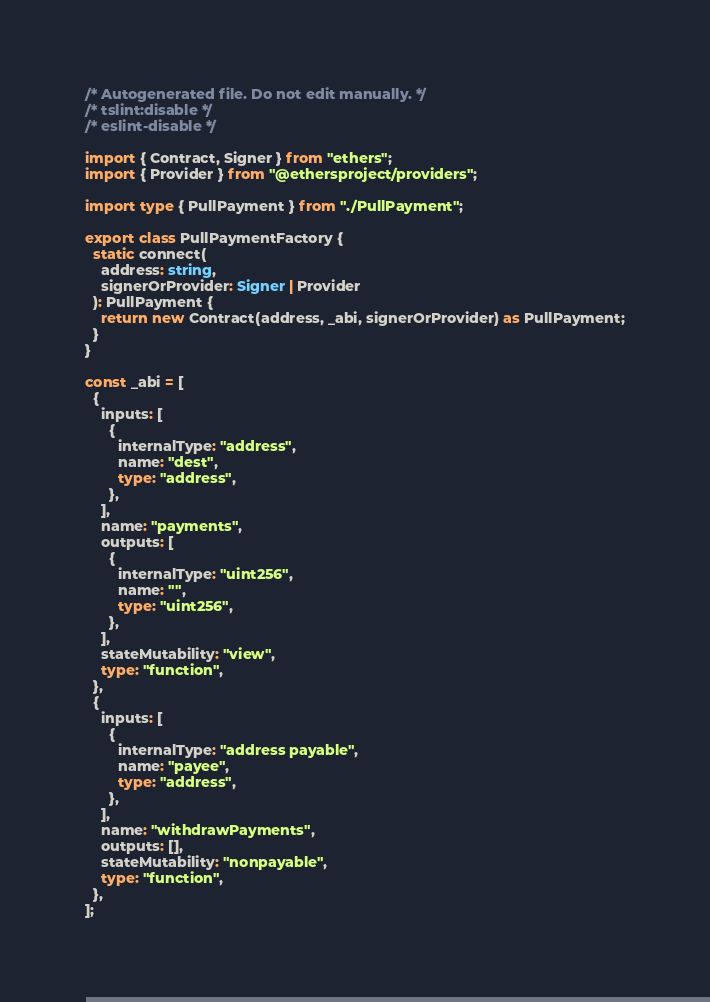<code> <loc_0><loc_0><loc_500><loc_500><_TypeScript_>/* Autogenerated file. Do not edit manually. */
/* tslint:disable */
/* eslint-disable */

import { Contract, Signer } from "ethers";
import { Provider } from "@ethersproject/providers";

import type { PullPayment } from "./PullPayment";

export class PullPaymentFactory {
  static connect(
    address: string,
    signerOrProvider: Signer | Provider
  ): PullPayment {
    return new Contract(address, _abi, signerOrProvider) as PullPayment;
  }
}

const _abi = [
  {
    inputs: [
      {
        internalType: "address",
        name: "dest",
        type: "address",
      },
    ],
    name: "payments",
    outputs: [
      {
        internalType: "uint256",
        name: "",
        type: "uint256",
      },
    ],
    stateMutability: "view",
    type: "function",
  },
  {
    inputs: [
      {
        internalType: "address payable",
        name: "payee",
        type: "address",
      },
    ],
    name: "withdrawPayments",
    outputs: [],
    stateMutability: "nonpayable",
    type: "function",
  },
];
</code> 